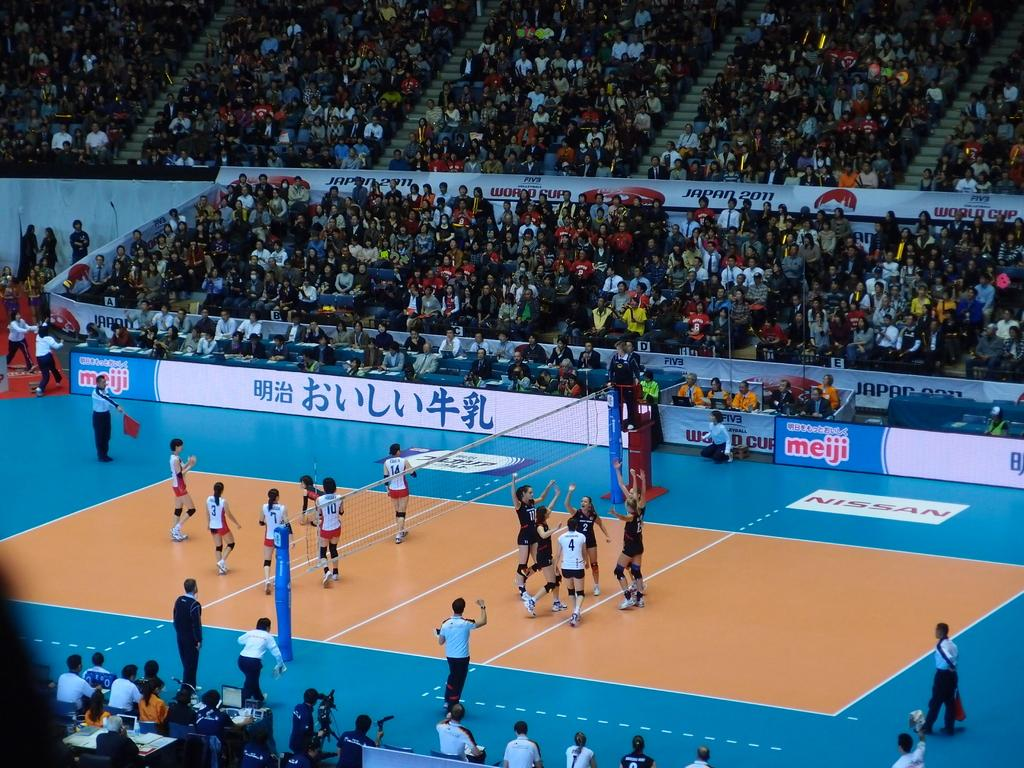<image>
Share a concise interpretation of the image provided. A volleyball court that advertises Meiji on the side 